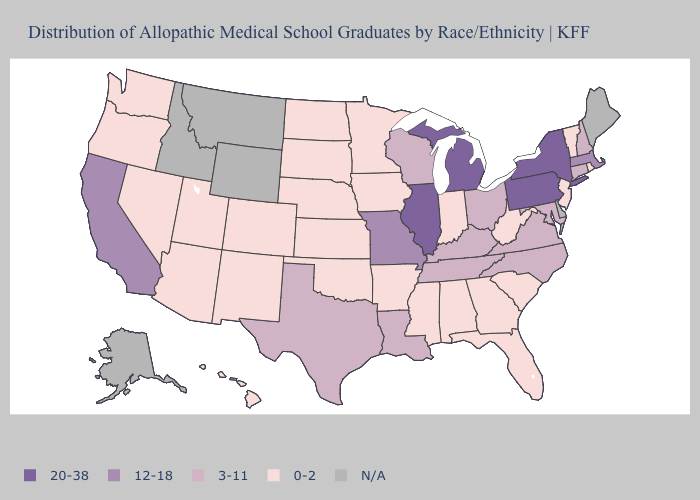Does New Hampshire have the lowest value in the USA?
Short answer required. No. What is the lowest value in the USA?
Short answer required. 0-2. Does the map have missing data?
Quick response, please. Yes. What is the value of Kentucky?
Give a very brief answer. 3-11. How many symbols are there in the legend?
Quick response, please. 5. What is the highest value in the USA?
Write a very short answer. 20-38. Name the states that have a value in the range N/A?
Write a very short answer. Alaska, Delaware, Idaho, Maine, Montana, Wyoming. What is the lowest value in states that border New Mexico?
Concise answer only. 0-2. Which states have the highest value in the USA?
Keep it brief. Illinois, Michigan, New York, Pennsylvania. Does Iowa have the highest value in the MidWest?
Be succinct. No. Name the states that have a value in the range 12-18?
Keep it brief. California, Massachusetts, Missouri. What is the value of Louisiana?
Concise answer only. 3-11. What is the highest value in the South ?
Write a very short answer. 3-11. 